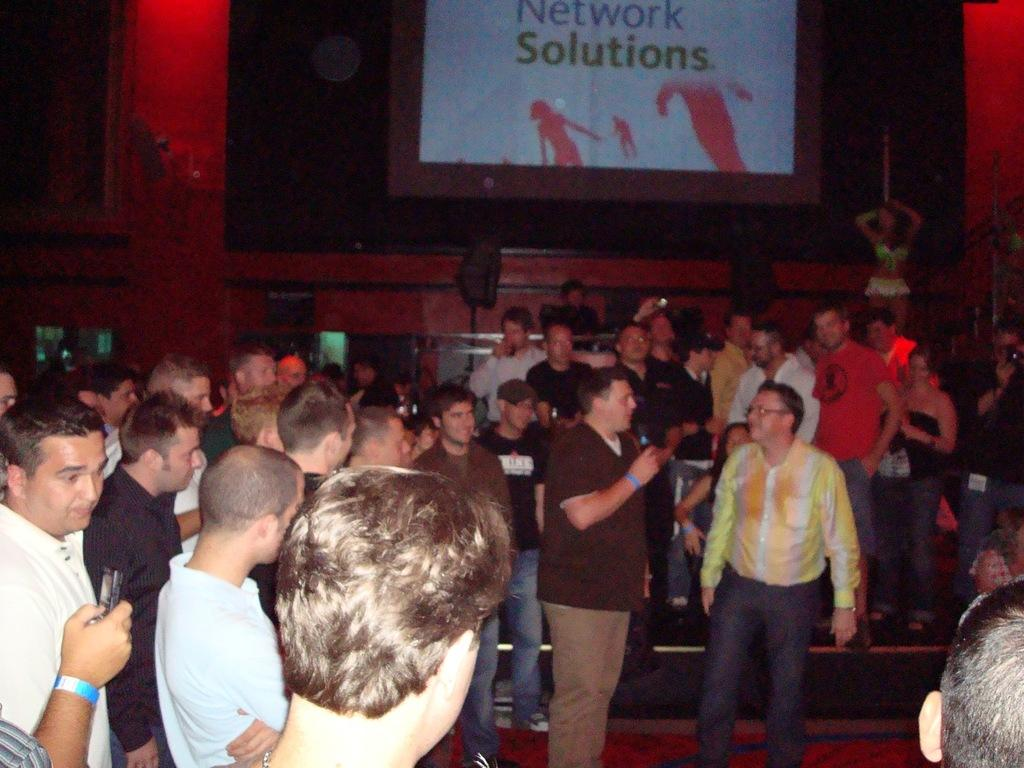What is the main subject of the image? The main subject of the image is a crowd. What can be seen in the background of the image? There is a screen with writing in the background. What is the person in the front holding? The person in the front is holding a microphone. What detail can be observed about some of the people in the crowd? Some people in the crowd are wearing wristbands. What type of plants can be seen growing on the person holding the microphone? There are no plants visible on the person holding the microphone in the image. 